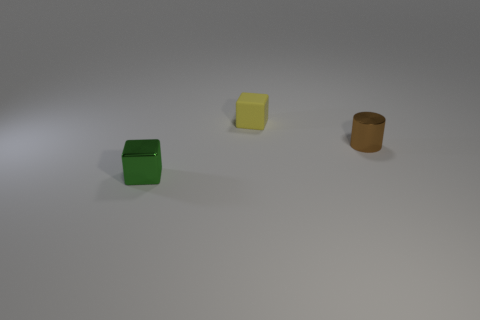Add 1 yellow rubber cubes. How many objects exist? 4 Subtract all cylinders. How many objects are left? 2 Add 2 tiny metallic cylinders. How many tiny metallic cylinders are left? 3 Add 2 small shiny cubes. How many small shiny cubes exist? 3 Subtract all green blocks. How many blocks are left? 1 Subtract 1 green blocks. How many objects are left? 2 Subtract 1 blocks. How many blocks are left? 1 Subtract all yellow cylinders. Subtract all red balls. How many cylinders are left? 1 Subtract all red cylinders. How many red cubes are left? 0 Subtract all large brown shiny spheres. Subtract all tiny matte objects. How many objects are left? 2 